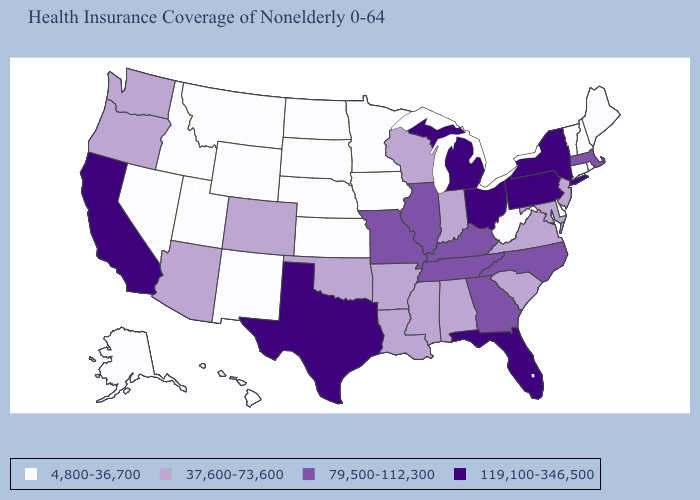What is the value of Wisconsin?
Quick response, please. 37,600-73,600. What is the lowest value in the USA?
Write a very short answer. 4,800-36,700. Which states have the lowest value in the MidWest?
Quick response, please. Iowa, Kansas, Minnesota, Nebraska, North Dakota, South Dakota. What is the value of Nevada?
Write a very short answer. 4,800-36,700. Name the states that have a value in the range 119,100-346,500?
Concise answer only. California, Florida, Michigan, New York, Ohio, Pennsylvania, Texas. Among the states that border Illinois , which have the highest value?
Concise answer only. Kentucky, Missouri. How many symbols are there in the legend?
Be succinct. 4. Among the states that border Michigan , which have the lowest value?
Quick response, please. Indiana, Wisconsin. Does Colorado have a lower value than Louisiana?
Short answer required. No. Does the map have missing data?
Short answer required. No. Does Florida have the highest value in the USA?
Be succinct. Yes. What is the value of Arkansas?
Answer briefly. 37,600-73,600. Name the states that have a value in the range 37,600-73,600?
Give a very brief answer. Alabama, Arizona, Arkansas, Colorado, Indiana, Louisiana, Maryland, Mississippi, New Jersey, Oklahoma, Oregon, South Carolina, Virginia, Washington, Wisconsin. Does Alaska have the lowest value in the West?
Give a very brief answer. Yes. Name the states that have a value in the range 79,500-112,300?
Short answer required. Georgia, Illinois, Kentucky, Massachusetts, Missouri, North Carolina, Tennessee. 